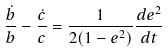Convert formula to latex. <formula><loc_0><loc_0><loc_500><loc_500>\frac { \dot { b } } { b } - \frac { \dot { c } } { c } = \frac { 1 } { 2 ( 1 - e ^ { 2 } ) } \frac { d e ^ { 2 } } { d t }</formula> 